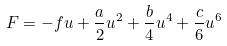<formula> <loc_0><loc_0><loc_500><loc_500>F = - f u + \frac { a } { 2 } u ^ { 2 } + \frac { b } { 4 } u ^ { 4 } + \frac { c } { 6 } u ^ { 6 }</formula> 